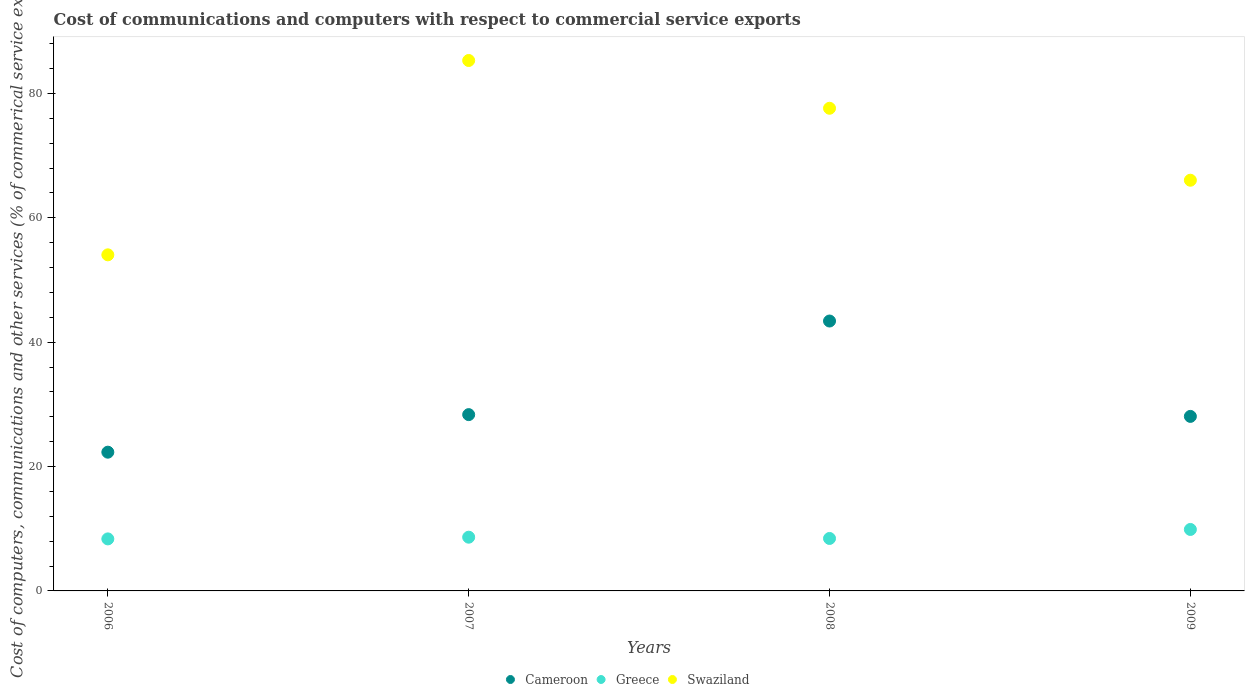How many different coloured dotlines are there?
Provide a succinct answer. 3. Is the number of dotlines equal to the number of legend labels?
Ensure brevity in your answer.  Yes. What is the cost of communications and computers in Swaziland in 2007?
Provide a succinct answer. 85.29. Across all years, what is the maximum cost of communications and computers in Swaziland?
Keep it short and to the point. 85.29. Across all years, what is the minimum cost of communications and computers in Cameroon?
Offer a terse response. 22.31. In which year was the cost of communications and computers in Greece maximum?
Make the answer very short. 2009. What is the total cost of communications and computers in Cameroon in the graph?
Your answer should be compact. 122.12. What is the difference between the cost of communications and computers in Swaziland in 2007 and that in 2008?
Keep it short and to the point. 7.68. What is the difference between the cost of communications and computers in Cameroon in 2006 and the cost of communications and computers in Greece in 2008?
Your answer should be very brief. 13.87. What is the average cost of communications and computers in Greece per year?
Make the answer very short. 8.83. In the year 2007, what is the difference between the cost of communications and computers in Swaziland and cost of communications and computers in Cameroon?
Provide a succinct answer. 56.94. In how many years, is the cost of communications and computers in Swaziland greater than 56 %?
Offer a very short reply. 3. What is the ratio of the cost of communications and computers in Greece in 2006 to that in 2008?
Ensure brevity in your answer.  0.99. Is the cost of communications and computers in Swaziland in 2007 less than that in 2008?
Your answer should be very brief. No. Is the difference between the cost of communications and computers in Swaziland in 2008 and 2009 greater than the difference between the cost of communications and computers in Cameroon in 2008 and 2009?
Offer a terse response. No. What is the difference between the highest and the second highest cost of communications and computers in Greece?
Your answer should be compact. 1.24. What is the difference between the highest and the lowest cost of communications and computers in Greece?
Make the answer very short. 1.52. In how many years, is the cost of communications and computers in Cameroon greater than the average cost of communications and computers in Cameroon taken over all years?
Your answer should be compact. 1. Is the sum of the cost of communications and computers in Swaziland in 2008 and 2009 greater than the maximum cost of communications and computers in Greece across all years?
Offer a very short reply. Yes. Is the cost of communications and computers in Greece strictly greater than the cost of communications and computers in Swaziland over the years?
Offer a terse response. No. Is the cost of communications and computers in Cameroon strictly less than the cost of communications and computers in Swaziland over the years?
Keep it short and to the point. Yes. How many dotlines are there?
Give a very brief answer. 3. How many years are there in the graph?
Offer a very short reply. 4. What is the difference between two consecutive major ticks on the Y-axis?
Ensure brevity in your answer.  20. Where does the legend appear in the graph?
Provide a succinct answer. Bottom center. How are the legend labels stacked?
Your response must be concise. Horizontal. What is the title of the graph?
Offer a terse response. Cost of communications and computers with respect to commercial service exports. What is the label or title of the Y-axis?
Ensure brevity in your answer.  Cost of computers, communications and other services (% of commerical service exports). What is the Cost of computers, communications and other services (% of commerical service exports) of Cameroon in 2006?
Keep it short and to the point. 22.31. What is the Cost of computers, communications and other services (% of commerical service exports) in Greece in 2006?
Give a very brief answer. 8.36. What is the Cost of computers, communications and other services (% of commerical service exports) in Swaziland in 2006?
Give a very brief answer. 54.04. What is the Cost of computers, communications and other services (% of commerical service exports) in Cameroon in 2007?
Offer a terse response. 28.35. What is the Cost of computers, communications and other services (% of commerical service exports) in Greece in 2007?
Offer a very short reply. 8.64. What is the Cost of computers, communications and other services (% of commerical service exports) of Swaziland in 2007?
Make the answer very short. 85.29. What is the Cost of computers, communications and other services (% of commerical service exports) of Cameroon in 2008?
Provide a short and direct response. 43.4. What is the Cost of computers, communications and other services (% of commerical service exports) in Greece in 2008?
Ensure brevity in your answer.  8.44. What is the Cost of computers, communications and other services (% of commerical service exports) in Swaziland in 2008?
Your answer should be very brief. 77.61. What is the Cost of computers, communications and other services (% of commerical service exports) in Cameroon in 2009?
Keep it short and to the point. 28.06. What is the Cost of computers, communications and other services (% of commerical service exports) of Greece in 2009?
Keep it short and to the point. 9.88. What is the Cost of computers, communications and other services (% of commerical service exports) in Swaziland in 2009?
Your answer should be very brief. 66.04. Across all years, what is the maximum Cost of computers, communications and other services (% of commerical service exports) of Cameroon?
Your answer should be compact. 43.4. Across all years, what is the maximum Cost of computers, communications and other services (% of commerical service exports) in Greece?
Your response must be concise. 9.88. Across all years, what is the maximum Cost of computers, communications and other services (% of commerical service exports) in Swaziland?
Your answer should be very brief. 85.29. Across all years, what is the minimum Cost of computers, communications and other services (% of commerical service exports) of Cameroon?
Give a very brief answer. 22.31. Across all years, what is the minimum Cost of computers, communications and other services (% of commerical service exports) in Greece?
Make the answer very short. 8.36. Across all years, what is the minimum Cost of computers, communications and other services (% of commerical service exports) in Swaziland?
Ensure brevity in your answer.  54.04. What is the total Cost of computers, communications and other services (% of commerical service exports) of Cameroon in the graph?
Make the answer very short. 122.12. What is the total Cost of computers, communications and other services (% of commerical service exports) of Greece in the graph?
Your answer should be compact. 35.33. What is the total Cost of computers, communications and other services (% of commerical service exports) of Swaziland in the graph?
Provide a short and direct response. 282.99. What is the difference between the Cost of computers, communications and other services (% of commerical service exports) in Cameroon in 2006 and that in 2007?
Provide a succinct answer. -6.04. What is the difference between the Cost of computers, communications and other services (% of commerical service exports) in Greece in 2006 and that in 2007?
Your answer should be very brief. -0.28. What is the difference between the Cost of computers, communications and other services (% of commerical service exports) in Swaziland in 2006 and that in 2007?
Your response must be concise. -31.25. What is the difference between the Cost of computers, communications and other services (% of commerical service exports) in Cameroon in 2006 and that in 2008?
Give a very brief answer. -21.09. What is the difference between the Cost of computers, communications and other services (% of commerical service exports) of Greece in 2006 and that in 2008?
Make the answer very short. -0.07. What is the difference between the Cost of computers, communications and other services (% of commerical service exports) in Swaziland in 2006 and that in 2008?
Your response must be concise. -23.57. What is the difference between the Cost of computers, communications and other services (% of commerical service exports) of Cameroon in 2006 and that in 2009?
Offer a terse response. -5.75. What is the difference between the Cost of computers, communications and other services (% of commerical service exports) in Greece in 2006 and that in 2009?
Give a very brief answer. -1.52. What is the difference between the Cost of computers, communications and other services (% of commerical service exports) in Swaziland in 2006 and that in 2009?
Ensure brevity in your answer.  -12. What is the difference between the Cost of computers, communications and other services (% of commerical service exports) of Cameroon in 2007 and that in 2008?
Your response must be concise. -15.05. What is the difference between the Cost of computers, communications and other services (% of commerical service exports) in Greece in 2007 and that in 2008?
Your answer should be compact. 0.2. What is the difference between the Cost of computers, communications and other services (% of commerical service exports) in Swaziland in 2007 and that in 2008?
Offer a very short reply. 7.68. What is the difference between the Cost of computers, communications and other services (% of commerical service exports) in Cameroon in 2007 and that in 2009?
Your answer should be compact. 0.28. What is the difference between the Cost of computers, communications and other services (% of commerical service exports) of Greece in 2007 and that in 2009?
Offer a very short reply. -1.24. What is the difference between the Cost of computers, communications and other services (% of commerical service exports) of Swaziland in 2007 and that in 2009?
Ensure brevity in your answer.  19.25. What is the difference between the Cost of computers, communications and other services (% of commerical service exports) in Cameroon in 2008 and that in 2009?
Your answer should be very brief. 15.34. What is the difference between the Cost of computers, communications and other services (% of commerical service exports) of Greece in 2008 and that in 2009?
Your answer should be compact. -1.45. What is the difference between the Cost of computers, communications and other services (% of commerical service exports) of Swaziland in 2008 and that in 2009?
Keep it short and to the point. 11.57. What is the difference between the Cost of computers, communications and other services (% of commerical service exports) in Cameroon in 2006 and the Cost of computers, communications and other services (% of commerical service exports) in Greece in 2007?
Your response must be concise. 13.67. What is the difference between the Cost of computers, communications and other services (% of commerical service exports) of Cameroon in 2006 and the Cost of computers, communications and other services (% of commerical service exports) of Swaziland in 2007?
Your answer should be compact. -62.98. What is the difference between the Cost of computers, communications and other services (% of commerical service exports) of Greece in 2006 and the Cost of computers, communications and other services (% of commerical service exports) of Swaziland in 2007?
Keep it short and to the point. -76.93. What is the difference between the Cost of computers, communications and other services (% of commerical service exports) in Cameroon in 2006 and the Cost of computers, communications and other services (% of commerical service exports) in Greece in 2008?
Provide a short and direct response. 13.87. What is the difference between the Cost of computers, communications and other services (% of commerical service exports) of Cameroon in 2006 and the Cost of computers, communications and other services (% of commerical service exports) of Swaziland in 2008?
Your answer should be very brief. -55.3. What is the difference between the Cost of computers, communications and other services (% of commerical service exports) in Greece in 2006 and the Cost of computers, communications and other services (% of commerical service exports) in Swaziland in 2008?
Give a very brief answer. -69.25. What is the difference between the Cost of computers, communications and other services (% of commerical service exports) in Cameroon in 2006 and the Cost of computers, communications and other services (% of commerical service exports) in Greece in 2009?
Your answer should be compact. 12.43. What is the difference between the Cost of computers, communications and other services (% of commerical service exports) in Cameroon in 2006 and the Cost of computers, communications and other services (% of commerical service exports) in Swaziland in 2009?
Make the answer very short. -43.73. What is the difference between the Cost of computers, communications and other services (% of commerical service exports) of Greece in 2006 and the Cost of computers, communications and other services (% of commerical service exports) of Swaziland in 2009?
Keep it short and to the point. -57.68. What is the difference between the Cost of computers, communications and other services (% of commerical service exports) in Cameroon in 2007 and the Cost of computers, communications and other services (% of commerical service exports) in Greece in 2008?
Your response must be concise. 19.91. What is the difference between the Cost of computers, communications and other services (% of commerical service exports) in Cameroon in 2007 and the Cost of computers, communications and other services (% of commerical service exports) in Swaziland in 2008?
Keep it short and to the point. -49.26. What is the difference between the Cost of computers, communications and other services (% of commerical service exports) of Greece in 2007 and the Cost of computers, communications and other services (% of commerical service exports) of Swaziland in 2008?
Provide a succinct answer. -68.97. What is the difference between the Cost of computers, communications and other services (% of commerical service exports) in Cameroon in 2007 and the Cost of computers, communications and other services (% of commerical service exports) in Greece in 2009?
Make the answer very short. 18.46. What is the difference between the Cost of computers, communications and other services (% of commerical service exports) of Cameroon in 2007 and the Cost of computers, communications and other services (% of commerical service exports) of Swaziland in 2009?
Offer a terse response. -37.69. What is the difference between the Cost of computers, communications and other services (% of commerical service exports) in Greece in 2007 and the Cost of computers, communications and other services (% of commerical service exports) in Swaziland in 2009?
Offer a terse response. -57.4. What is the difference between the Cost of computers, communications and other services (% of commerical service exports) in Cameroon in 2008 and the Cost of computers, communications and other services (% of commerical service exports) in Greece in 2009?
Ensure brevity in your answer.  33.52. What is the difference between the Cost of computers, communications and other services (% of commerical service exports) of Cameroon in 2008 and the Cost of computers, communications and other services (% of commerical service exports) of Swaziland in 2009?
Keep it short and to the point. -22.64. What is the difference between the Cost of computers, communications and other services (% of commerical service exports) in Greece in 2008 and the Cost of computers, communications and other services (% of commerical service exports) in Swaziland in 2009?
Your answer should be compact. -57.6. What is the average Cost of computers, communications and other services (% of commerical service exports) in Cameroon per year?
Provide a succinct answer. 30.53. What is the average Cost of computers, communications and other services (% of commerical service exports) in Greece per year?
Keep it short and to the point. 8.83. What is the average Cost of computers, communications and other services (% of commerical service exports) in Swaziland per year?
Make the answer very short. 70.75. In the year 2006, what is the difference between the Cost of computers, communications and other services (% of commerical service exports) of Cameroon and Cost of computers, communications and other services (% of commerical service exports) of Greece?
Provide a succinct answer. 13.95. In the year 2006, what is the difference between the Cost of computers, communications and other services (% of commerical service exports) of Cameroon and Cost of computers, communications and other services (% of commerical service exports) of Swaziland?
Your answer should be compact. -31.73. In the year 2006, what is the difference between the Cost of computers, communications and other services (% of commerical service exports) in Greece and Cost of computers, communications and other services (% of commerical service exports) in Swaziland?
Give a very brief answer. -45.68. In the year 2007, what is the difference between the Cost of computers, communications and other services (% of commerical service exports) in Cameroon and Cost of computers, communications and other services (% of commerical service exports) in Greece?
Give a very brief answer. 19.71. In the year 2007, what is the difference between the Cost of computers, communications and other services (% of commerical service exports) of Cameroon and Cost of computers, communications and other services (% of commerical service exports) of Swaziland?
Provide a short and direct response. -56.94. In the year 2007, what is the difference between the Cost of computers, communications and other services (% of commerical service exports) of Greece and Cost of computers, communications and other services (% of commerical service exports) of Swaziland?
Your answer should be very brief. -76.65. In the year 2008, what is the difference between the Cost of computers, communications and other services (% of commerical service exports) in Cameroon and Cost of computers, communications and other services (% of commerical service exports) in Greece?
Provide a short and direct response. 34.96. In the year 2008, what is the difference between the Cost of computers, communications and other services (% of commerical service exports) of Cameroon and Cost of computers, communications and other services (% of commerical service exports) of Swaziland?
Offer a very short reply. -34.21. In the year 2008, what is the difference between the Cost of computers, communications and other services (% of commerical service exports) of Greece and Cost of computers, communications and other services (% of commerical service exports) of Swaziland?
Ensure brevity in your answer.  -69.18. In the year 2009, what is the difference between the Cost of computers, communications and other services (% of commerical service exports) of Cameroon and Cost of computers, communications and other services (% of commerical service exports) of Greece?
Provide a short and direct response. 18.18. In the year 2009, what is the difference between the Cost of computers, communications and other services (% of commerical service exports) of Cameroon and Cost of computers, communications and other services (% of commerical service exports) of Swaziland?
Ensure brevity in your answer.  -37.98. In the year 2009, what is the difference between the Cost of computers, communications and other services (% of commerical service exports) of Greece and Cost of computers, communications and other services (% of commerical service exports) of Swaziland?
Offer a very short reply. -56.16. What is the ratio of the Cost of computers, communications and other services (% of commerical service exports) of Cameroon in 2006 to that in 2007?
Provide a short and direct response. 0.79. What is the ratio of the Cost of computers, communications and other services (% of commerical service exports) in Greece in 2006 to that in 2007?
Provide a succinct answer. 0.97. What is the ratio of the Cost of computers, communications and other services (% of commerical service exports) of Swaziland in 2006 to that in 2007?
Your response must be concise. 0.63. What is the ratio of the Cost of computers, communications and other services (% of commerical service exports) in Cameroon in 2006 to that in 2008?
Keep it short and to the point. 0.51. What is the ratio of the Cost of computers, communications and other services (% of commerical service exports) of Greece in 2006 to that in 2008?
Your answer should be compact. 0.99. What is the ratio of the Cost of computers, communications and other services (% of commerical service exports) in Swaziland in 2006 to that in 2008?
Make the answer very short. 0.7. What is the ratio of the Cost of computers, communications and other services (% of commerical service exports) of Cameroon in 2006 to that in 2009?
Give a very brief answer. 0.79. What is the ratio of the Cost of computers, communications and other services (% of commerical service exports) of Greece in 2006 to that in 2009?
Keep it short and to the point. 0.85. What is the ratio of the Cost of computers, communications and other services (% of commerical service exports) of Swaziland in 2006 to that in 2009?
Your answer should be compact. 0.82. What is the ratio of the Cost of computers, communications and other services (% of commerical service exports) of Cameroon in 2007 to that in 2008?
Your response must be concise. 0.65. What is the ratio of the Cost of computers, communications and other services (% of commerical service exports) in Greece in 2007 to that in 2008?
Your response must be concise. 1.02. What is the ratio of the Cost of computers, communications and other services (% of commerical service exports) of Swaziland in 2007 to that in 2008?
Offer a very short reply. 1.1. What is the ratio of the Cost of computers, communications and other services (% of commerical service exports) of Cameroon in 2007 to that in 2009?
Provide a short and direct response. 1.01. What is the ratio of the Cost of computers, communications and other services (% of commerical service exports) in Greece in 2007 to that in 2009?
Your answer should be very brief. 0.87. What is the ratio of the Cost of computers, communications and other services (% of commerical service exports) in Swaziland in 2007 to that in 2009?
Provide a succinct answer. 1.29. What is the ratio of the Cost of computers, communications and other services (% of commerical service exports) in Cameroon in 2008 to that in 2009?
Ensure brevity in your answer.  1.55. What is the ratio of the Cost of computers, communications and other services (% of commerical service exports) in Greece in 2008 to that in 2009?
Your answer should be compact. 0.85. What is the ratio of the Cost of computers, communications and other services (% of commerical service exports) of Swaziland in 2008 to that in 2009?
Your response must be concise. 1.18. What is the difference between the highest and the second highest Cost of computers, communications and other services (% of commerical service exports) of Cameroon?
Ensure brevity in your answer.  15.05. What is the difference between the highest and the second highest Cost of computers, communications and other services (% of commerical service exports) in Greece?
Your answer should be compact. 1.24. What is the difference between the highest and the second highest Cost of computers, communications and other services (% of commerical service exports) in Swaziland?
Ensure brevity in your answer.  7.68. What is the difference between the highest and the lowest Cost of computers, communications and other services (% of commerical service exports) of Cameroon?
Make the answer very short. 21.09. What is the difference between the highest and the lowest Cost of computers, communications and other services (% of commerical service exports) of Greece?
Offer a very short reply. 1.52. What is the difference between the highest and the lowest Cost of computers, communications and other services (% of commerical service exports) in Swaziland?
Make the answer very short. 31.25. 